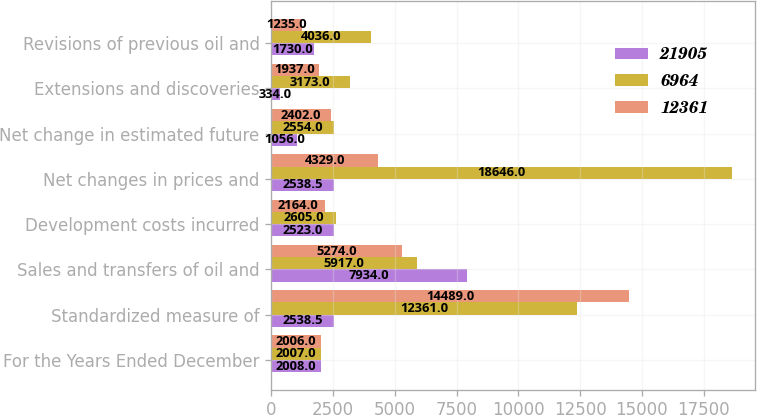Convert chart to OTSL. <chart><loc_0><loc_0><loc_500><loc_500><stacked_bar_chart><ecel><fcel>For the Years Ended December<fcel>Standardized measure of<fcel>Sales and transfers of oil and<fcel>Development costs incurred<fcel>Net changes in prices and<fcel>Net change in estimated future<fcel>Extensions and discoveries<fcel>Revisions of previous oil and<nl><fcel>21905<fcel>2008<fcel>2538.5<fcel>7934<fcel>2523<fcel>2538.5<fcel>1056<fcel>334<fcel>1730<nl><fcel>6964<fcel>2007<fcel>12361<fcel>5917<fcel>2605<fcel>18646<fcel>2554<fcel>3173<fcel>4036<nl><fcel>12361<fcel>2006<fcel>14489<fcel>5274<fcel>2164<fcel>4329<fcel>2402<fcel>1937<fcel>1235<nl></chart> 